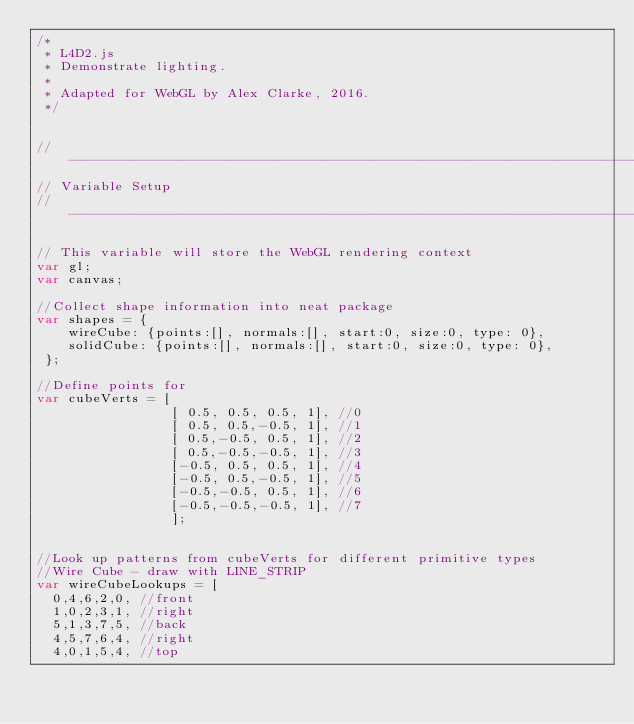<code> <loc_0><loc_0><loc_500><loc_500><_JavaScript_>/*
 * L4D2.js
 * Demonstrate lighting.
 *
 * Adapted for WebGL by Alex Clarke, 2016.
 */


//----------------------------------------------------------------------------
// Variable Setup
//----------------------------------------------------------------------------

// This variable will store the WebGL rendering context
var gl;
var canvas;

//Collect shape information into neat package
var shapes = {
    wireCube: {points:[], normals:[], start:0, size:0, type: 0},
    solidCube: {points:[], normals:[], start:0, size:0, type: 0},
 };

//Define points for
var cubeVerts = [
                 [ 0.5, 0.5, 0.5, 1], //0
                 [ 0.5, 0.5,-0.5, 1], //1
                 [ 0.5,-0.5, 0.5, 1], //2
                 [ 0.5,-0.5,-0.5, 1], //3
                 [-0.5, 0.5, 0.5, 1], //4
                 [-0.5, 0.5,-0.5, 1], //5
                 [-0.5,-0.5, 0.5, 1], //6
                 [-0.5,-0.5,-0.5, 1], //7
                 ];


//Look up patterns from cubeVerts for different primitive types
//Wire Cube - draw with LINE_STRIP
var wireCubeLookups = [
	0,4,6,2,0, //front
	1,0,2,3,1, //right
	5,1,3,7,5, //back
	4,5,7,6,4, //right
	4,0,1,5,4, //top</code> 